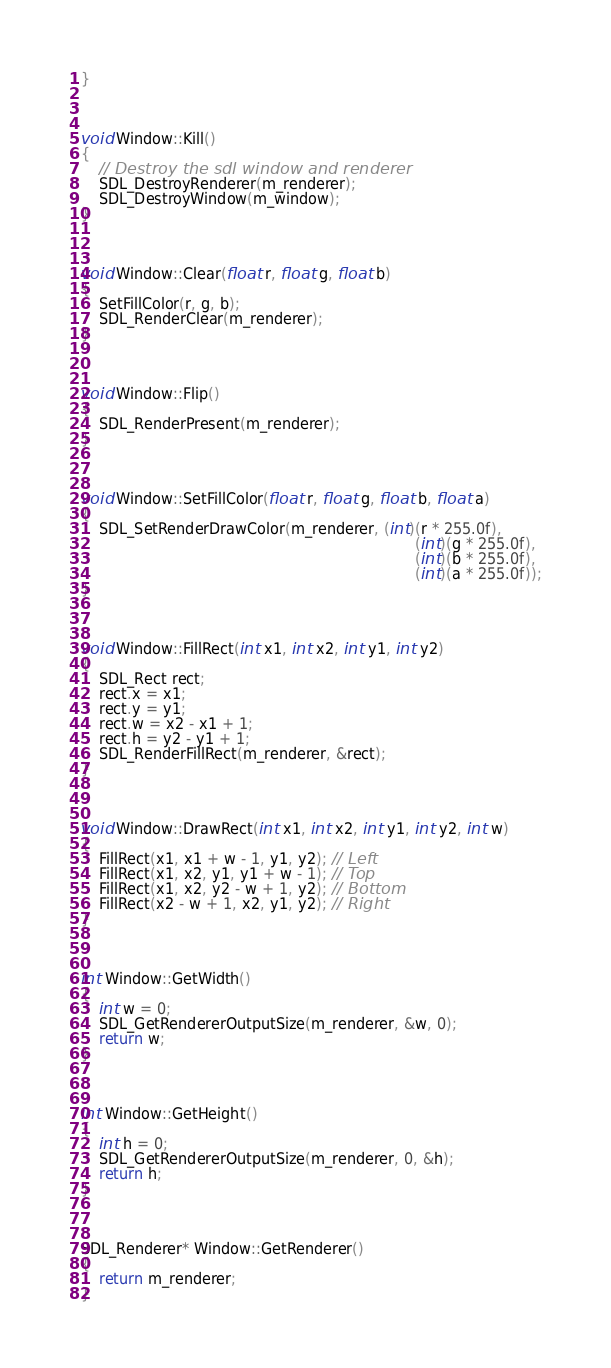<code> <loc_0><loc_0><loc_500><loc_500><_C++_>}



void Window::Kill()
{
	// Destroy the sdl window and renderer
	SDL_DestroyRenderer(m_renderer);
	SDL_DestroyWindow(m_window);
}



void Window::Clear(float r, float g, float b)
{
	SetFillColor(r, g, b);
	SDL_RenderClear(m_renderer);
}



void Window::Flip()
{
	SDL_RenderPresent(m_renderer);
}



void Window::SetFillColor(float r, float g, float b, float a)
{
	SDL_SetRenderDrawColor(m_renderer, (int)(r * 255.0f), 
																		 (int)(g * 255.0f), 
																		 (int)(b * 255.0f), 
																		 (int)(a * 255.0f));
}



void Window::FillRect(int x1, int x2, int y1, int y2)
{
	SDL_Rect rect;
	rect.x = x1;
	rect.y = y1;
	rect.w = x2 - x1 + 1;
	rect.h = y2 - y1 + 1;
	SDL_RenderFillRect(m_renderer, &rect);
}



void Window::DrawRect(int x1, int x2, int y1, int y2, int w)
{
	FillRect(x1, x1 + w - 1, y1, y2); // Left
	FillRect(x1, x2, y1, y1 + w - 1); // Top
	FillRect(x1, x2, y2 - w + 1, y2); // Bottom
	FillRect(x2 - w + 1, x2, y1, y2); // Right
}



int Window::GetWidth()
{
	int w = 0;
	SDL_GetRendererOutputSize(m_renderer, &w, 0);
	return w;
}



int Window::GetHeight()
{
	int h = 0;
	SDL_GetRendererOutputSize(m_renderer, 0, &h);
	return h;
}



SDL_Renderer* Window::GetRenderer()
{
	return m_renderer;
}
</code> 